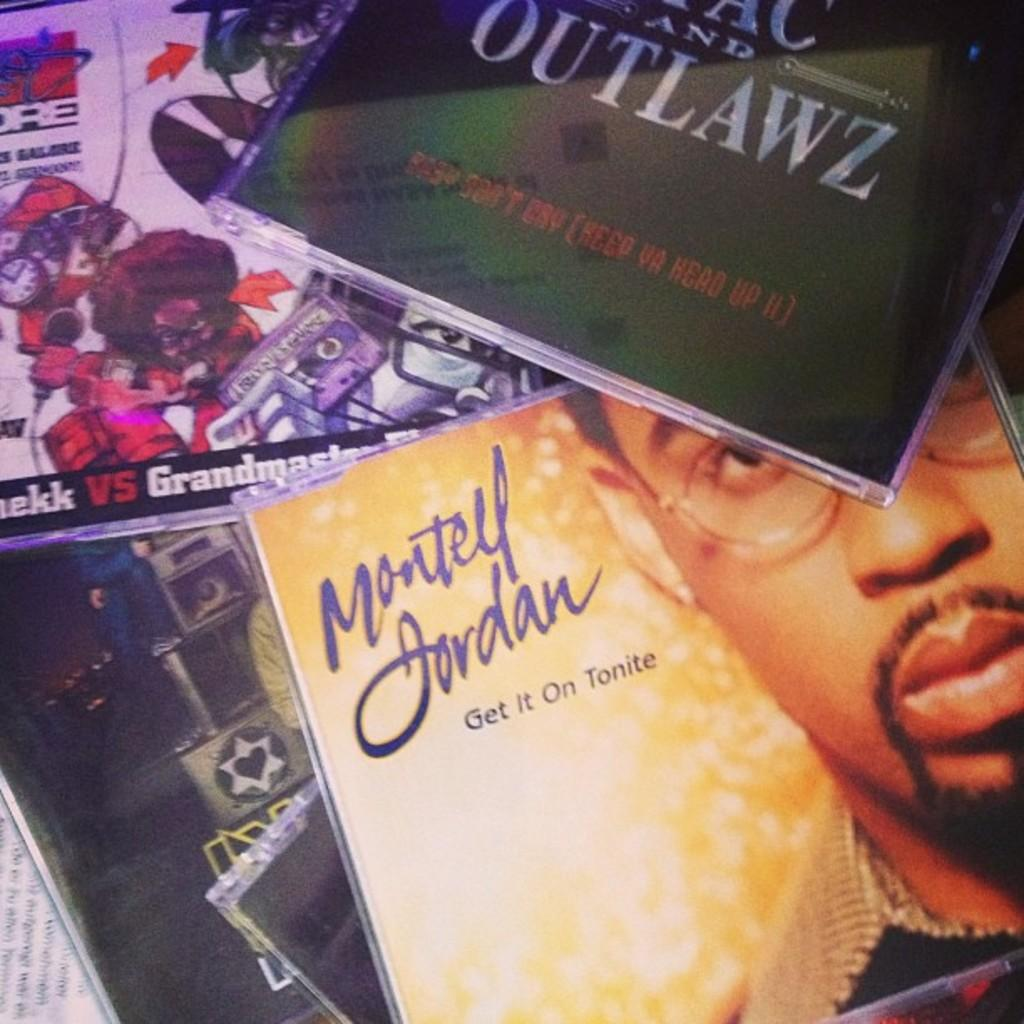<image>
Offer a succinct explanation of the picture presented. The CD collection includes Montell Jordan's Get it On Tonite. 